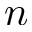<formula> <loc_0><loc_0><loc_500><loc_500>n</formula> 